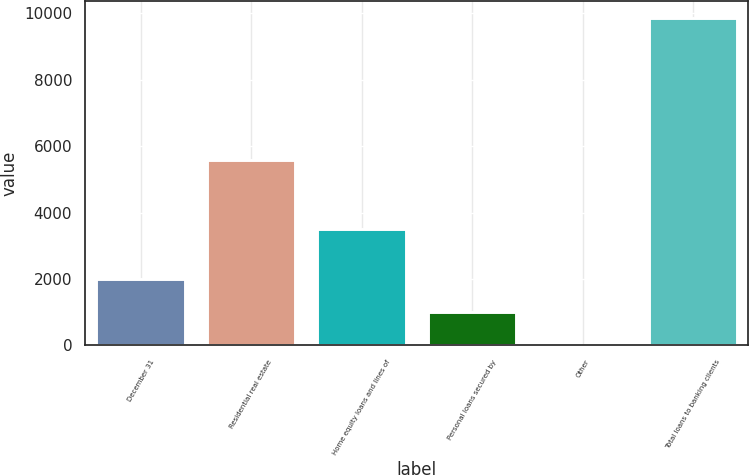Convert chart. <chart><loc_0><loc_0><loc_500><loc_500><bar_chart><fcel>December 31<fcel>Residential real estate<fcel>Home equity loans and lines of<fcel>Personal loans secured by<fcel>Other<fcel>Total loans to banking clients<nl><fcel>2011<fcel>5596<fcel>3509<fcel>1000.7<fcel>16<fcel>9863<nl></chart> 